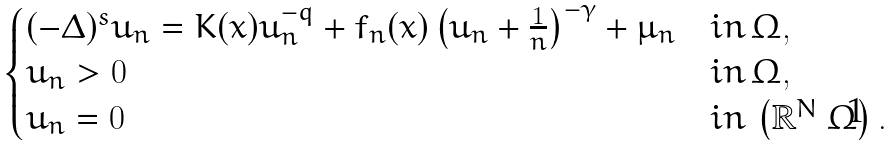Convert formula to latex. <formula><loc_0><loc_0><loc_500><loc_500>\begin{cases} ( - \Delta ) ^ { s } u _ { n } = K ( x ) u _ { n } ^ { - q } + f _ { n } ( x ) \left ( u _ { n } + \frac { 1 } { n } \right ) ^ { - \gamma } + \mu _ { n } & i n \, \Omega , \\ u _ { n } > 0 & i n \, \Omega , \\ u _ { n } = 0 & i n \, \left ( \mathbb { R } ^ { N } \ \Omega \right ) . \end{cases}</formula> 